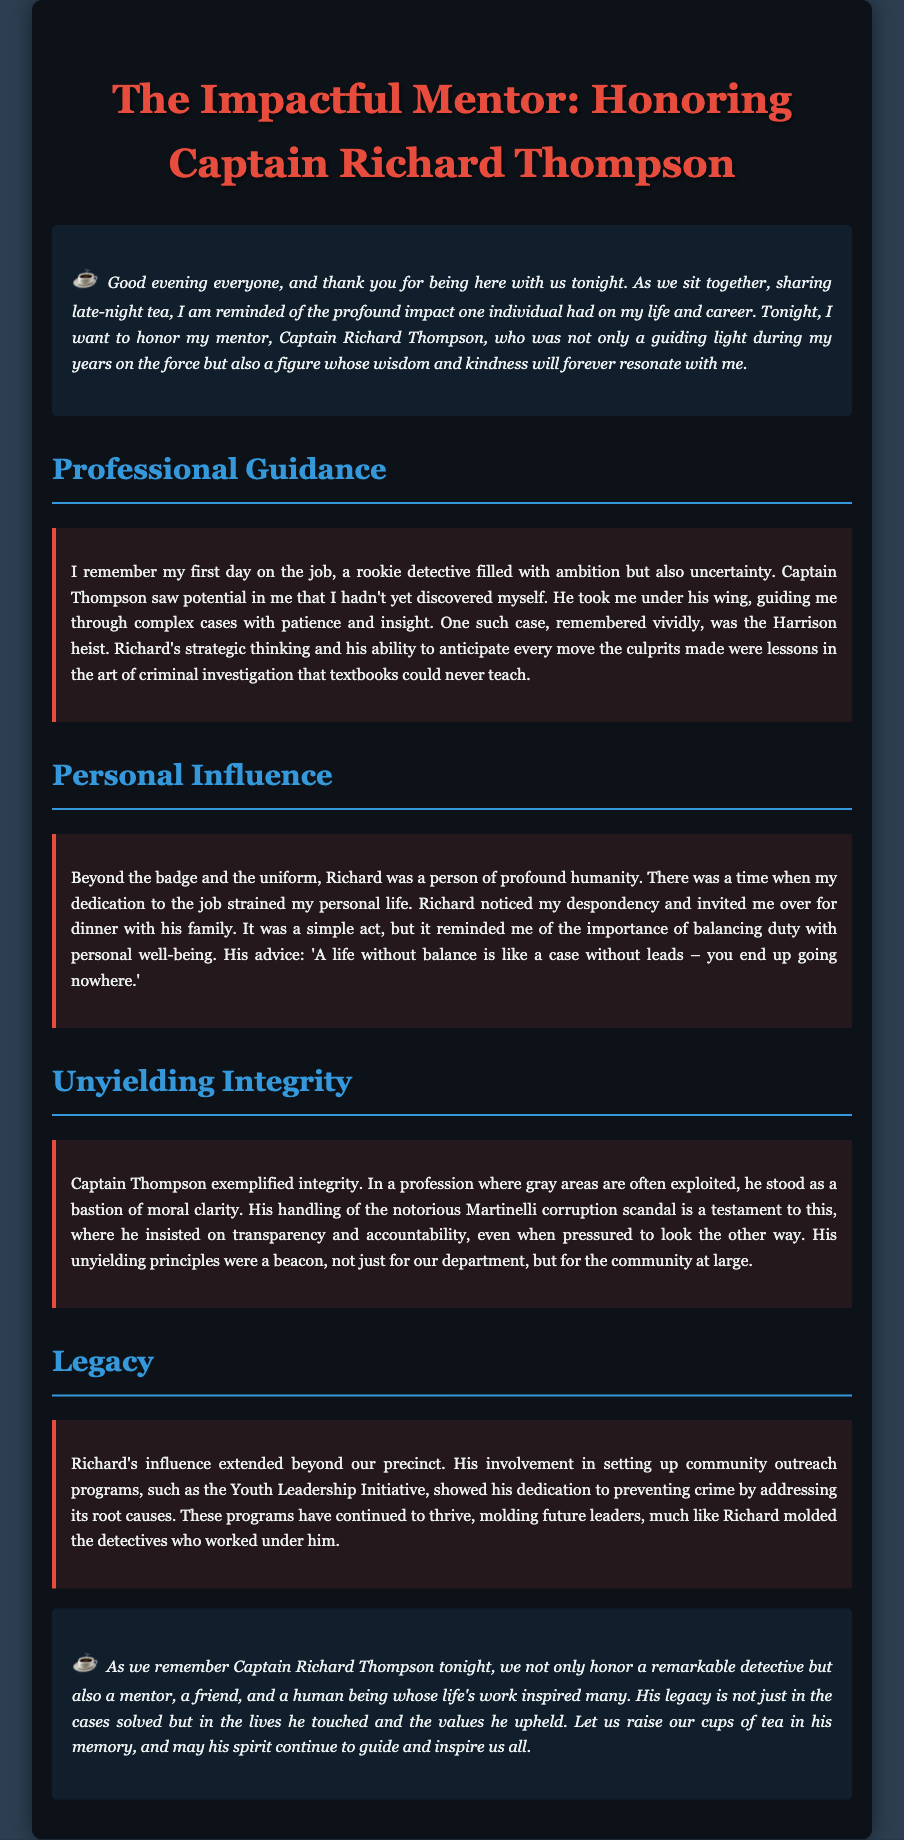What is the name of the mentor being honored? The eulogy is focused on Captain Richard Thompson, highlighting his significant impact.
Answer: Captain Richard Thompson What notable case did Captain Thompson guide the speaker through? The eulogy mentions a specific case called the Harrison heist, showcasing Thompson's mentoring capabilities.
Answer: Harrison heist What program did Captain Thompson help establish? The speaker references the Youth Leadership Initiative as one of the community outreach programs initiated by Thompson.
Answer: Youth Leadership Initiative What was Captain Thompson's advice regarding a balanced life? The eulogy quotes Thompson’s advice on life balance, emphasizing its importance through a metaphor related to investigations.
Answer: A life without balance is like a case without leads What important principle did Captain Thompson uphold during the Martinelli scandal? The document highlights Thompson's unwavering commitment to transparency and accountability amidst pressure.
Answer: Transparency and accountability What quality did Captain Thompson exemplify as a mentor? The eulogy emphasizes integrity as a defining characteristic of Thompson's mentorship style.
Answer: Integrity How does the speaker describe the personal impact of Captain Thompson? The text illustrates Thompson’s human qualities, demonstrating his concern for personal well-being alongside professional duties.
Answer: Humanity What is the overall tone of the eulogy? The eulogy conveys a tone of gratitude and reverence, celebrating the life and influence of Captain Thompson.
Answer: Gratitude and reverence 